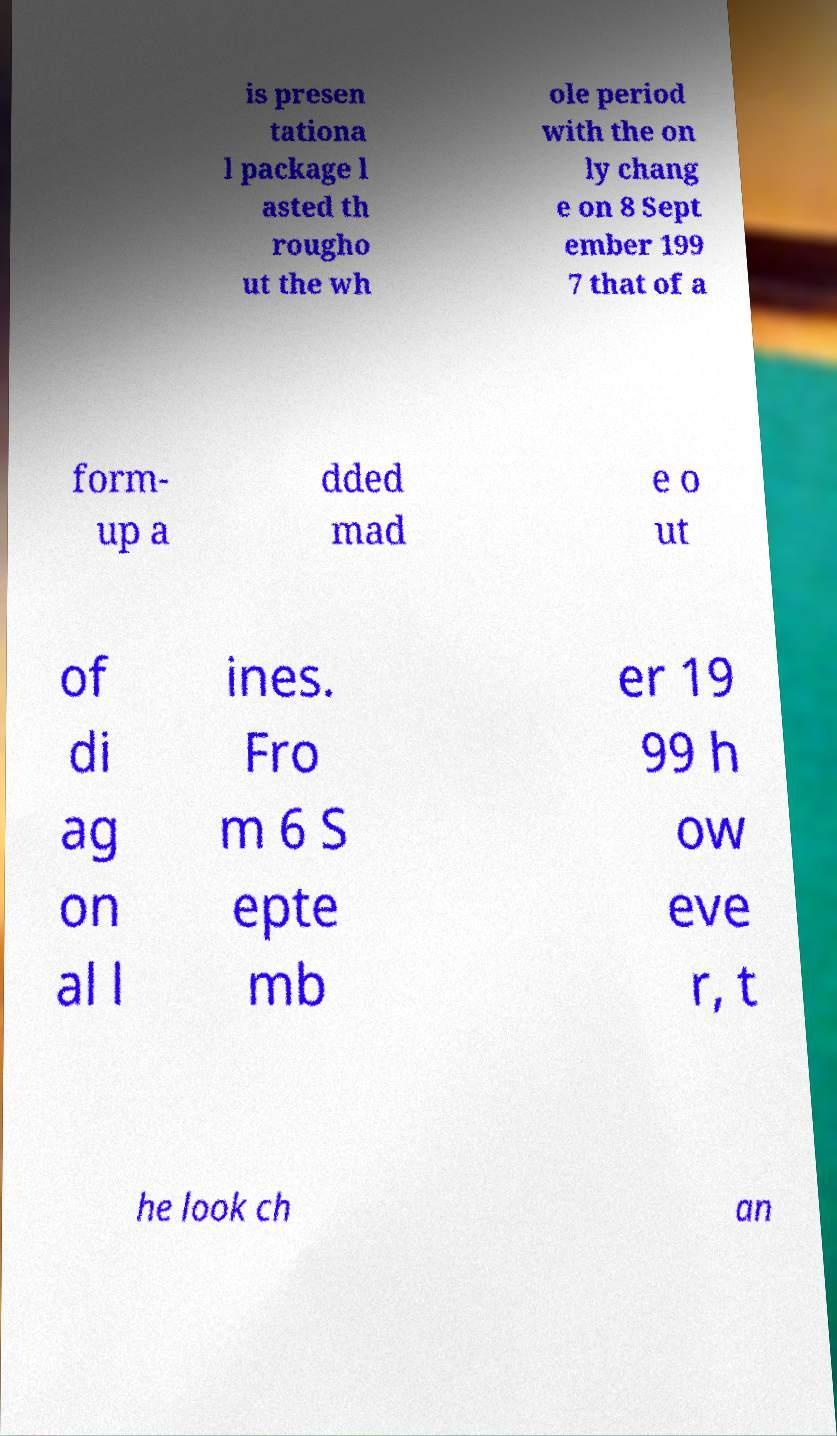Can you read and provide the text displayed in the image?This photo seems to have some interesting text. Can you extract and type it out for me? is presen tationa l package l asted th rougho ut the wh ole period with the on ly chang e on 8 Sept ember 199 7 that of a form- up a dded mad e o ut of di ag on al l ines. Fro m 6 S epte mb er 19 99 h ow eve r, t he look ch an 